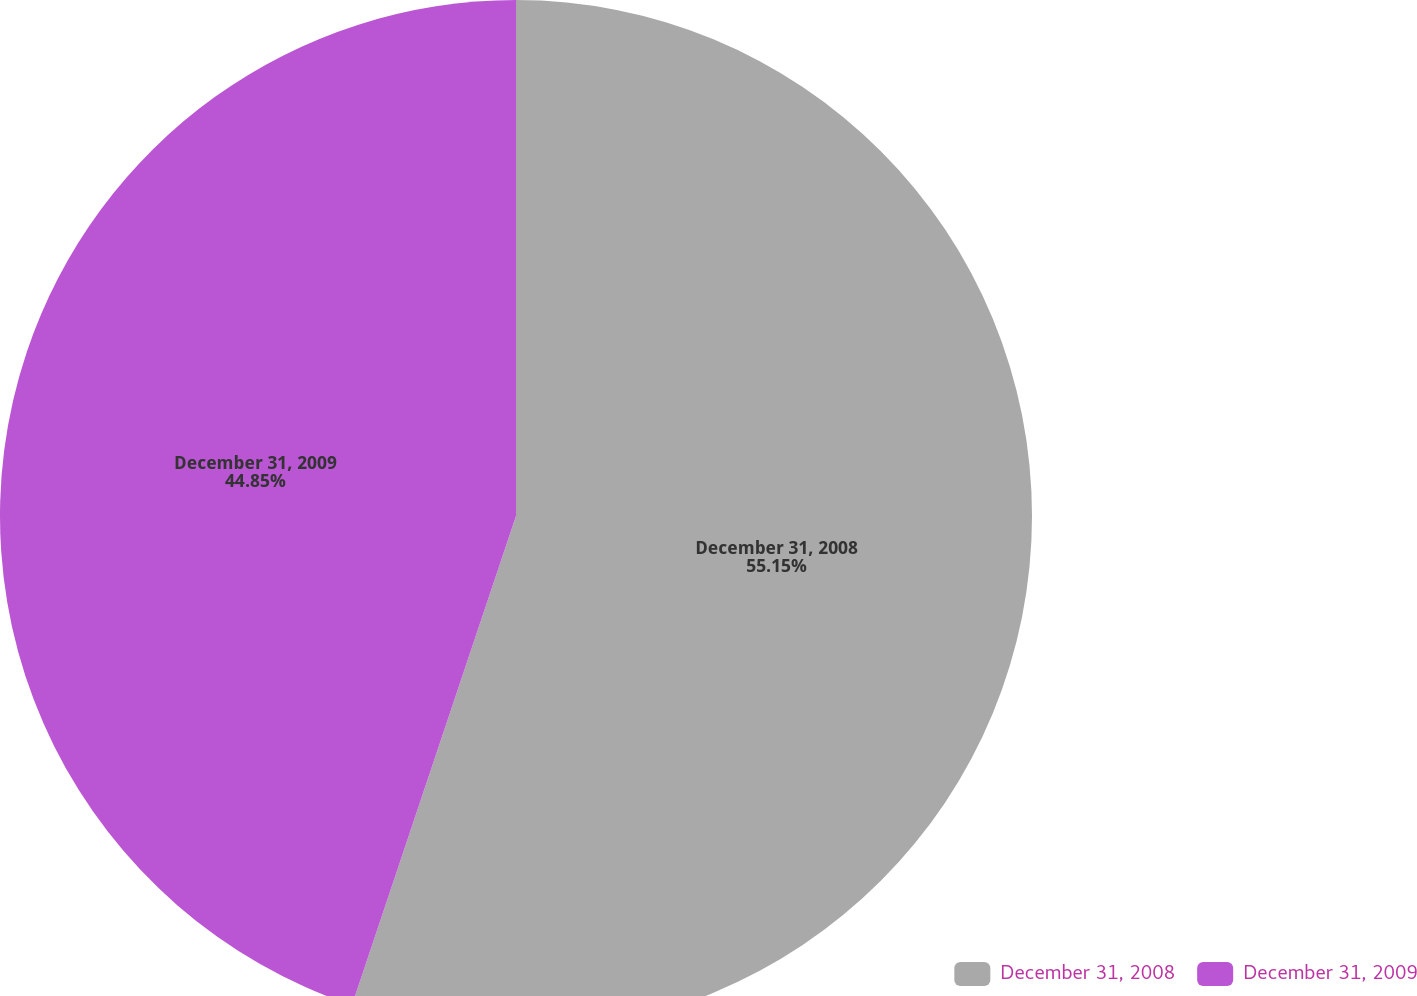Convert chart. <chart><loc_0><loc_0><loc_500><loc_500><pie_chart><fcel>December 31, 2008<fcel>December 31, 2009<nl><fcel>55.15%<fcel>44.85%<nl></chart> 